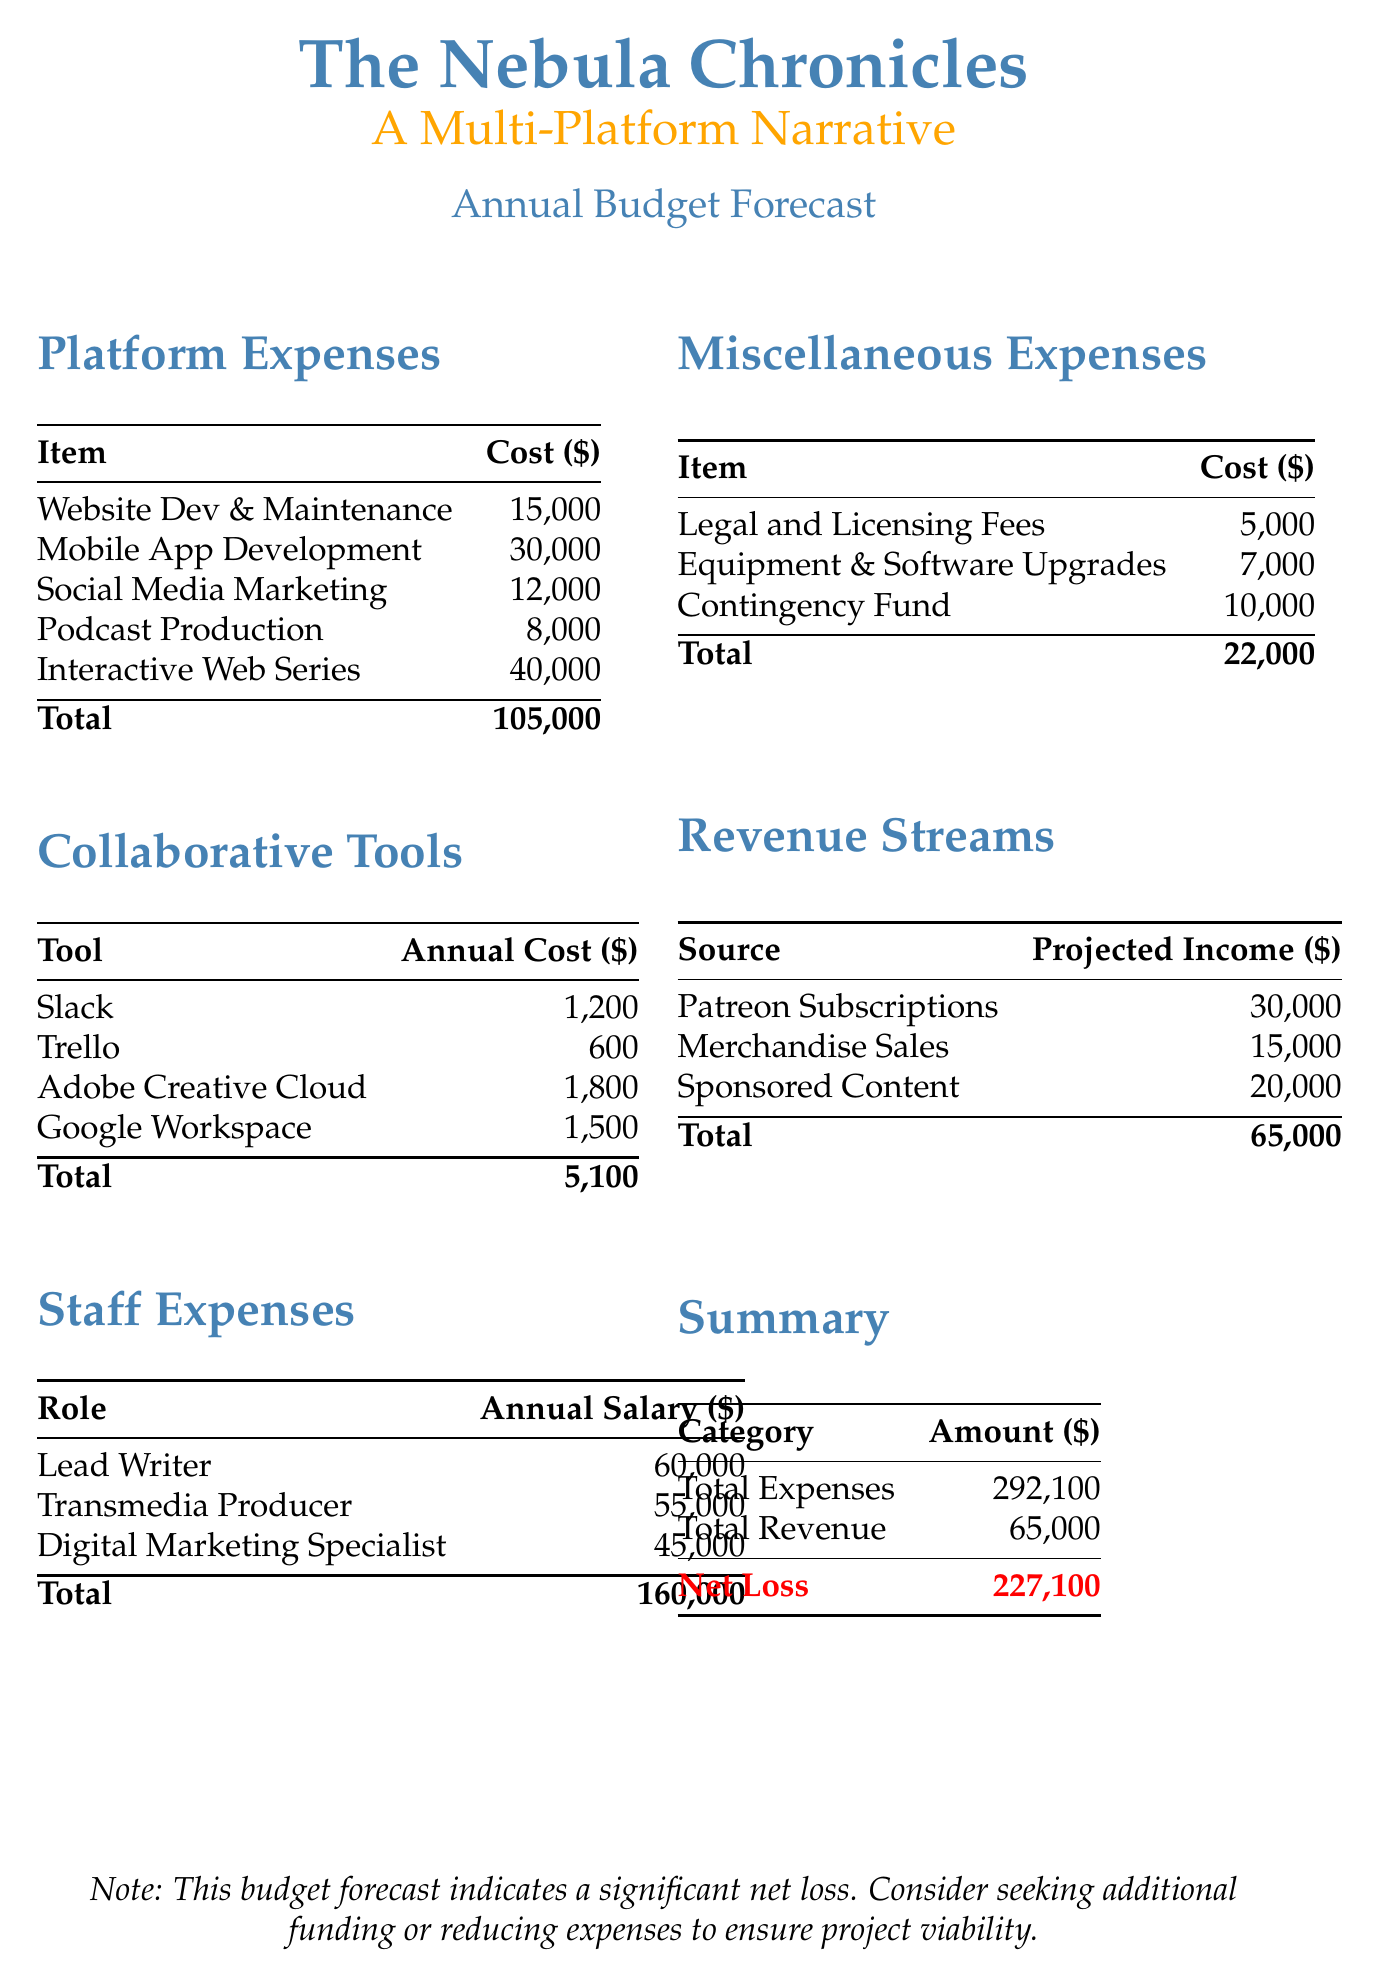What is the project name? The project name is stated at the beginning of the document.
Answer: The Nebula Chronicles: A Multi-Platform Narrative What is the total annual budget forecast? The total annual budget forecast is mentioned in the document as a single figure.
Answer: 150000 What is the cost for Mobile App Development? The cost for Mobile App Development is listed under Platform Expenses.
Answer: 30000 What is the total cost for collaborative tools? The total for collaborative tools is provided in the document within the respective table.
Answer: 5100 Who is the Lead Writer? The Lead Writer role is indicated in the Staff Expenses section of the document.
Answer: Lead Writer What are the projected annual incomes from Merchandise Sales? The projected income from Merchandise Sales can be found in the Revenue Streams section.
Answer: 15000 What is the total of miscellaneous expenses? The total amount for miscellaneous expenses is found in their corresponding table in the document.
Answer: 22000 What is the net loss according to the forecast? The net loss is calculated in the Summary section, showing the difference between total expenses and total revenue.
Answer: 227100 What is the purpose of the contingency fund? The contingency fund is typically used for unexpected expenses, as indicated in the Miscellaneous Expenses section.
Answer: 10000 